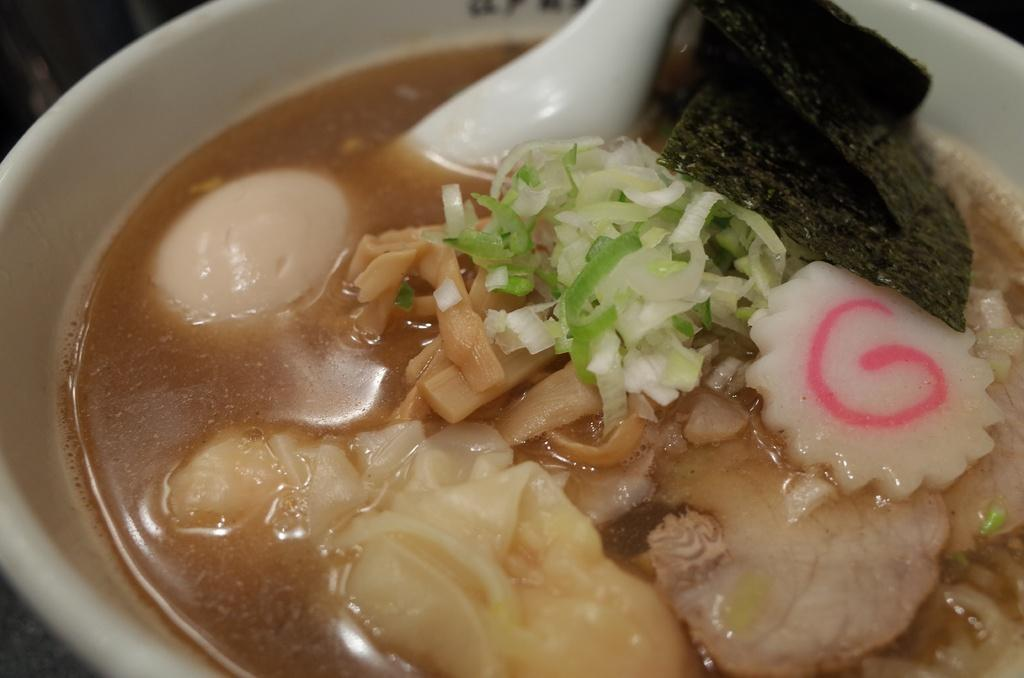What is present in the image that can be used for eating? There is a spoon in the image that can be used for eating. What is the main container for the food in the image? There is a bowl in the image that contains the food. What type of food can be seen in the image? The facts provided do not specify the type of food in the image. How many metal ladybugs can be seen crawling on the food in the image? There are no ladybugs, metal or otherwise, present in the image. 